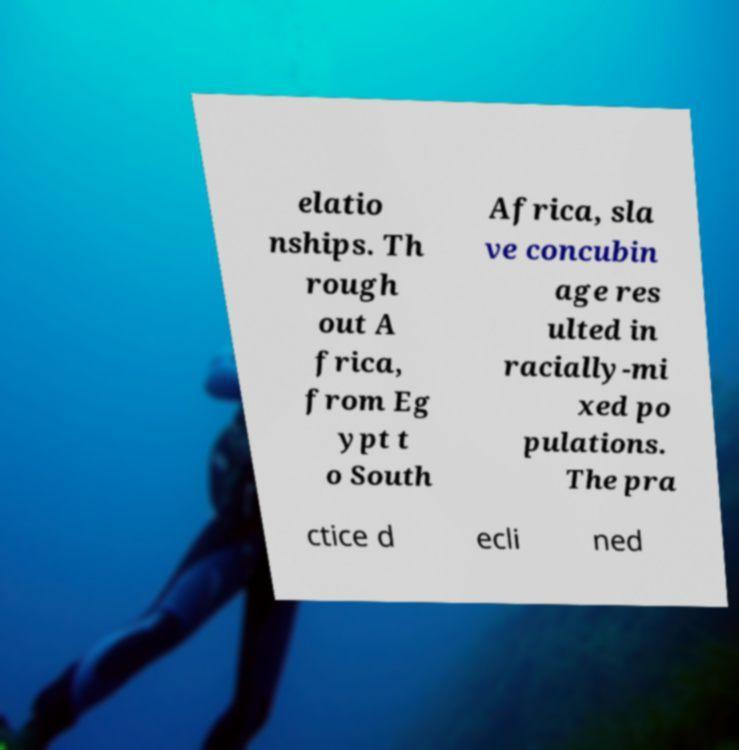Please identify and transcribe the text found in this image. elatio nships. Th rough out A frica, from Eg ypt t o South Africa, sla ve concubin age res ulted in racially-mi xed po pulations. The pra ctice d ecli ned 